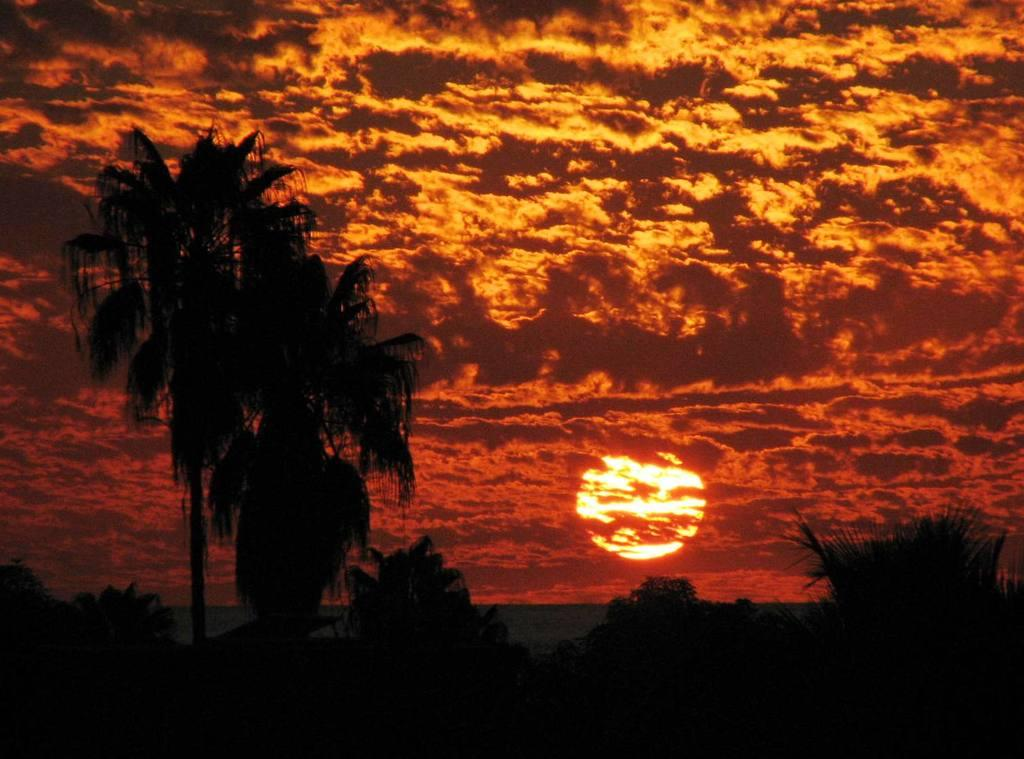What type of view is shown in the image? The image depicts a sunset view. What can be seen in the foreground of the image? There are coconut trees in the front of the image. What is the main celestial body visible in the image? The sun is visible in the middle of the image. How would you describe the color of the sky during the sunset? The sky is red during the sunset. Are there any other atmospheric features visible in the sky? Clouds are present in the sky. What type of club can be seen in the image? There is no club present in the image; it features a sunset view with coconut trees and a red sky. What type of rice is being cooked in the image? There is no rice or cooking activity depicted in the image. 